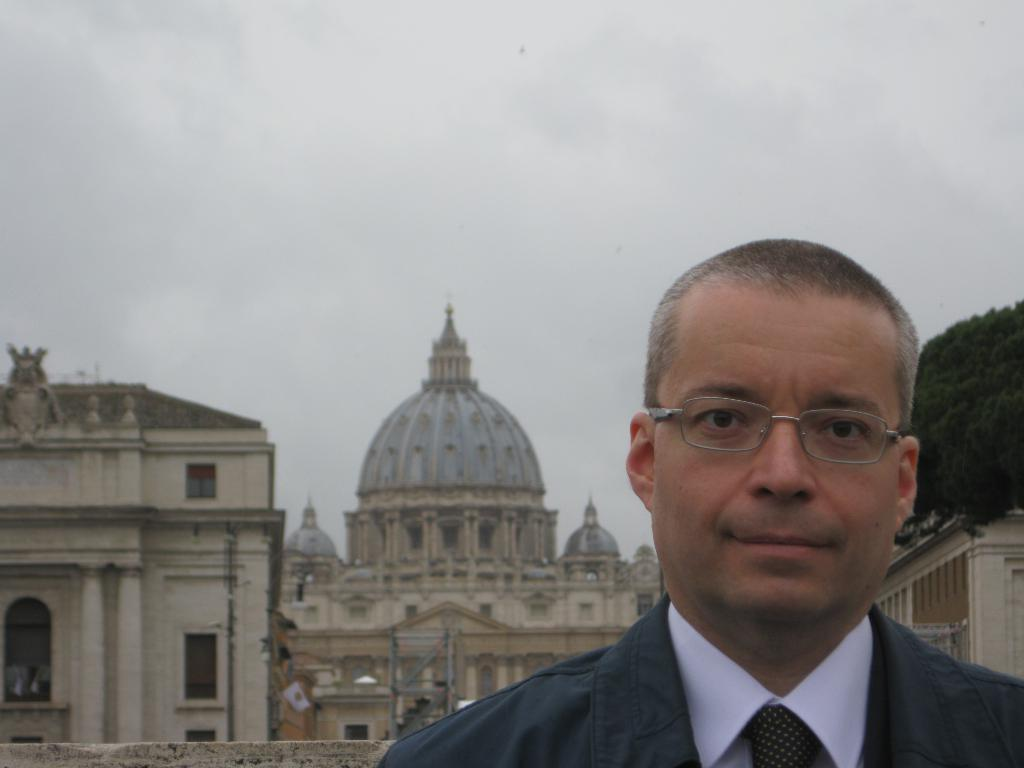Who or what is located at the bottom of the image? There is a person at the bottom of the image. What structures can be seen in the middle of the image? There are buildings and a fort visible in the middle of the image. What type of plant is on the right side of the image? There is a tree on the right side of the image. What is visible at the top of the image? The sky is visible at the top of the image. How many cats are climbing the tree in the image? There are no cats present in the image; it features a person, buildings, a fort, a tree, and the sky. What day of the week is depicted in the image? The image does not depict a specific day of the week. 